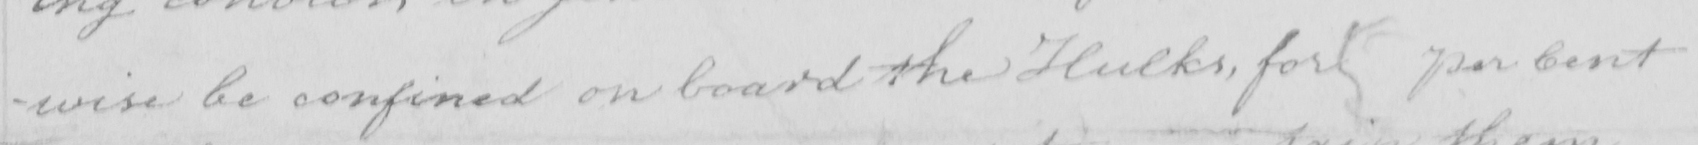Can you tell me what this handwritten text says? -wise be confined on board the Hulks , for per Cent 